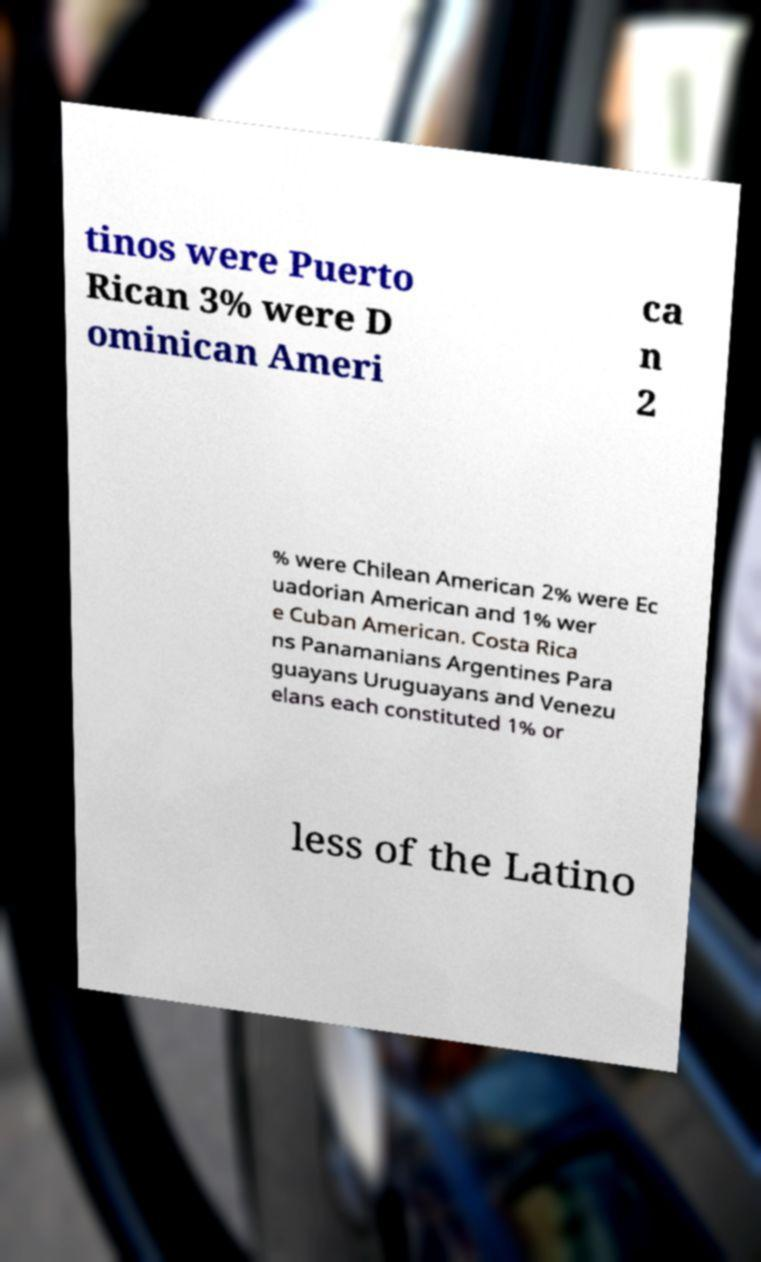I need the written content from this picture converted into text. Can you do that? tinos were Puerto Rican 3% were D ominican Ameri ca n 2 % were Chilean American 2% were Ec uadorian American and 1% wer e Cuban American. Costa Rica ns Panamanians Argentines Para guayans Uruguayans and Venezu elans each constituted 1% or less of the Latino 